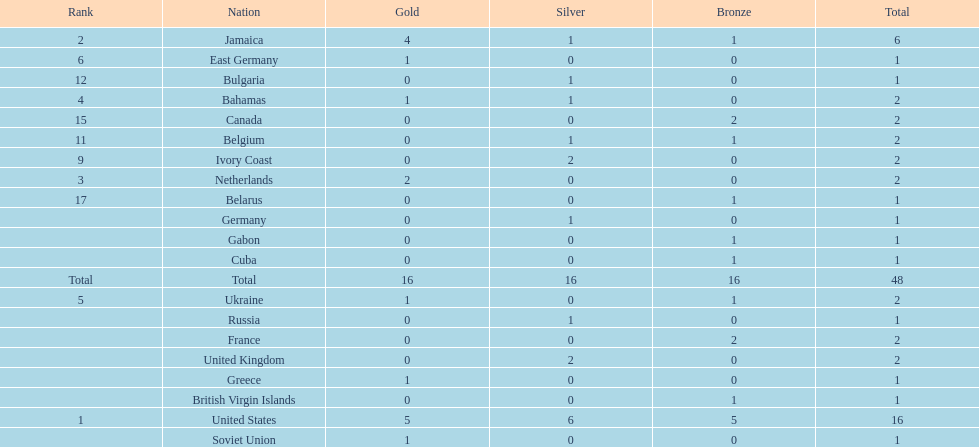How many nations won more than one silver medal? 3. 